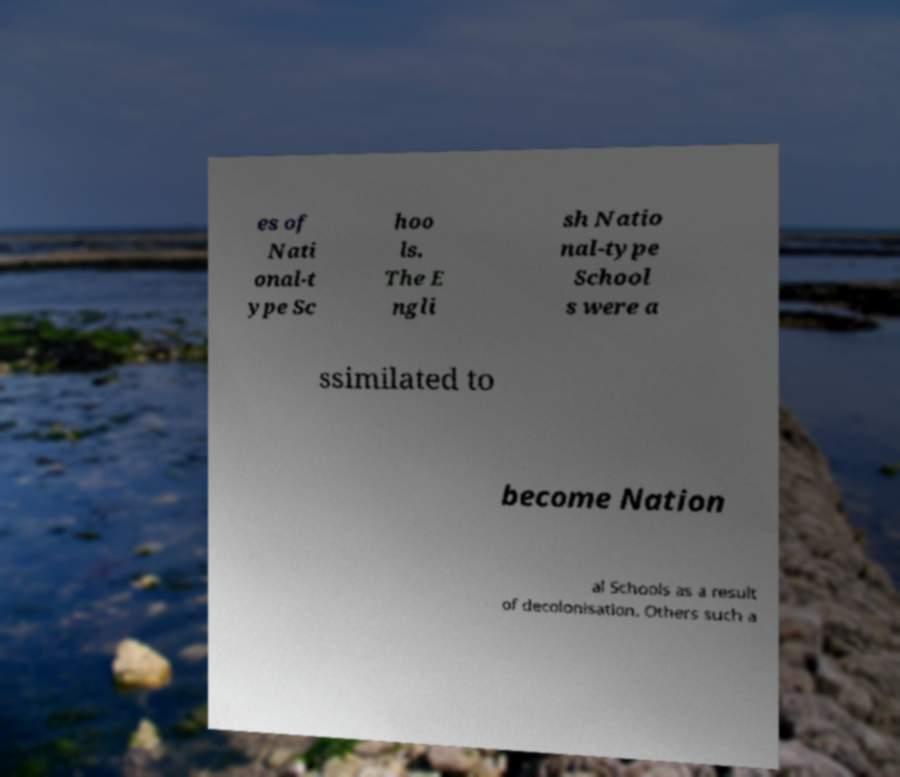Can you read and provide the text displayed in the image?This photo seems to have some interesting text. Can you extract and type it out for me? es of Nati onal-t ype Sc hoo ls. The E ngli sh Natio nal-type School s were a ssimilated to become Nation al Schools as a result of decolonisation. Others such a 